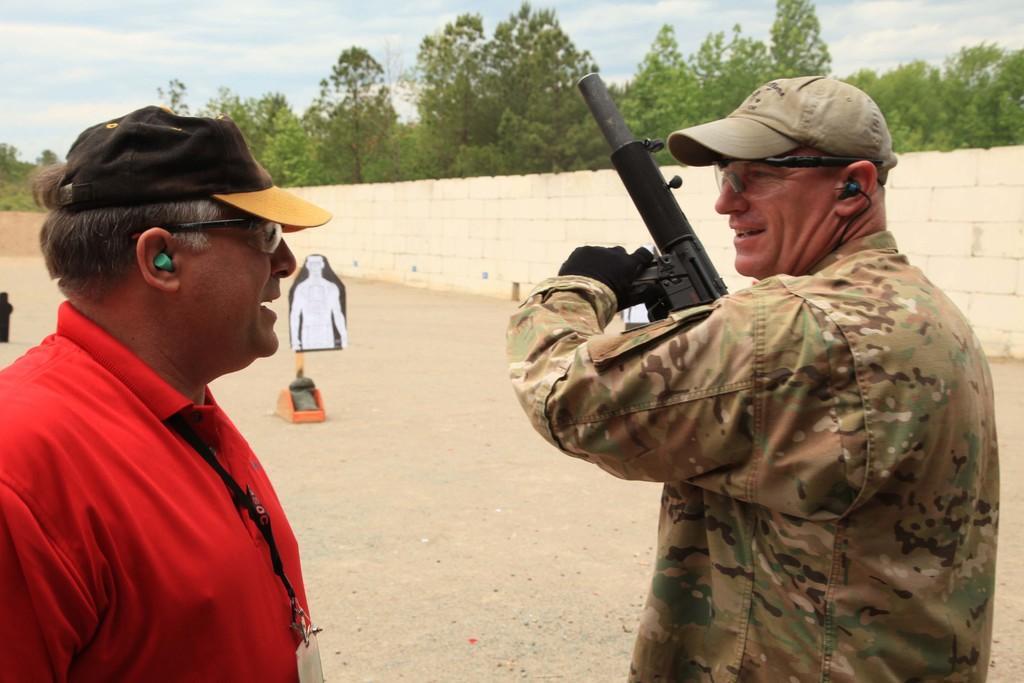Can you describe this image briefly? There is a man holding a gun and another man in the foreground area, there are trees, wall, it seems like a man on the poster and the sky in the background. 